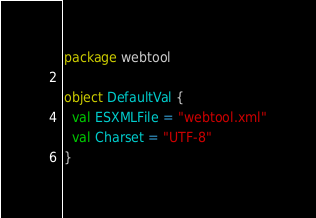<code> <loc_0><loc_0><loc_500><loc_500><_Scala_>package webtool

object DefaultVal {
  val ESXMLFile = "webtool.xml"
  val Charset = "UTF-8"
}
</code> 